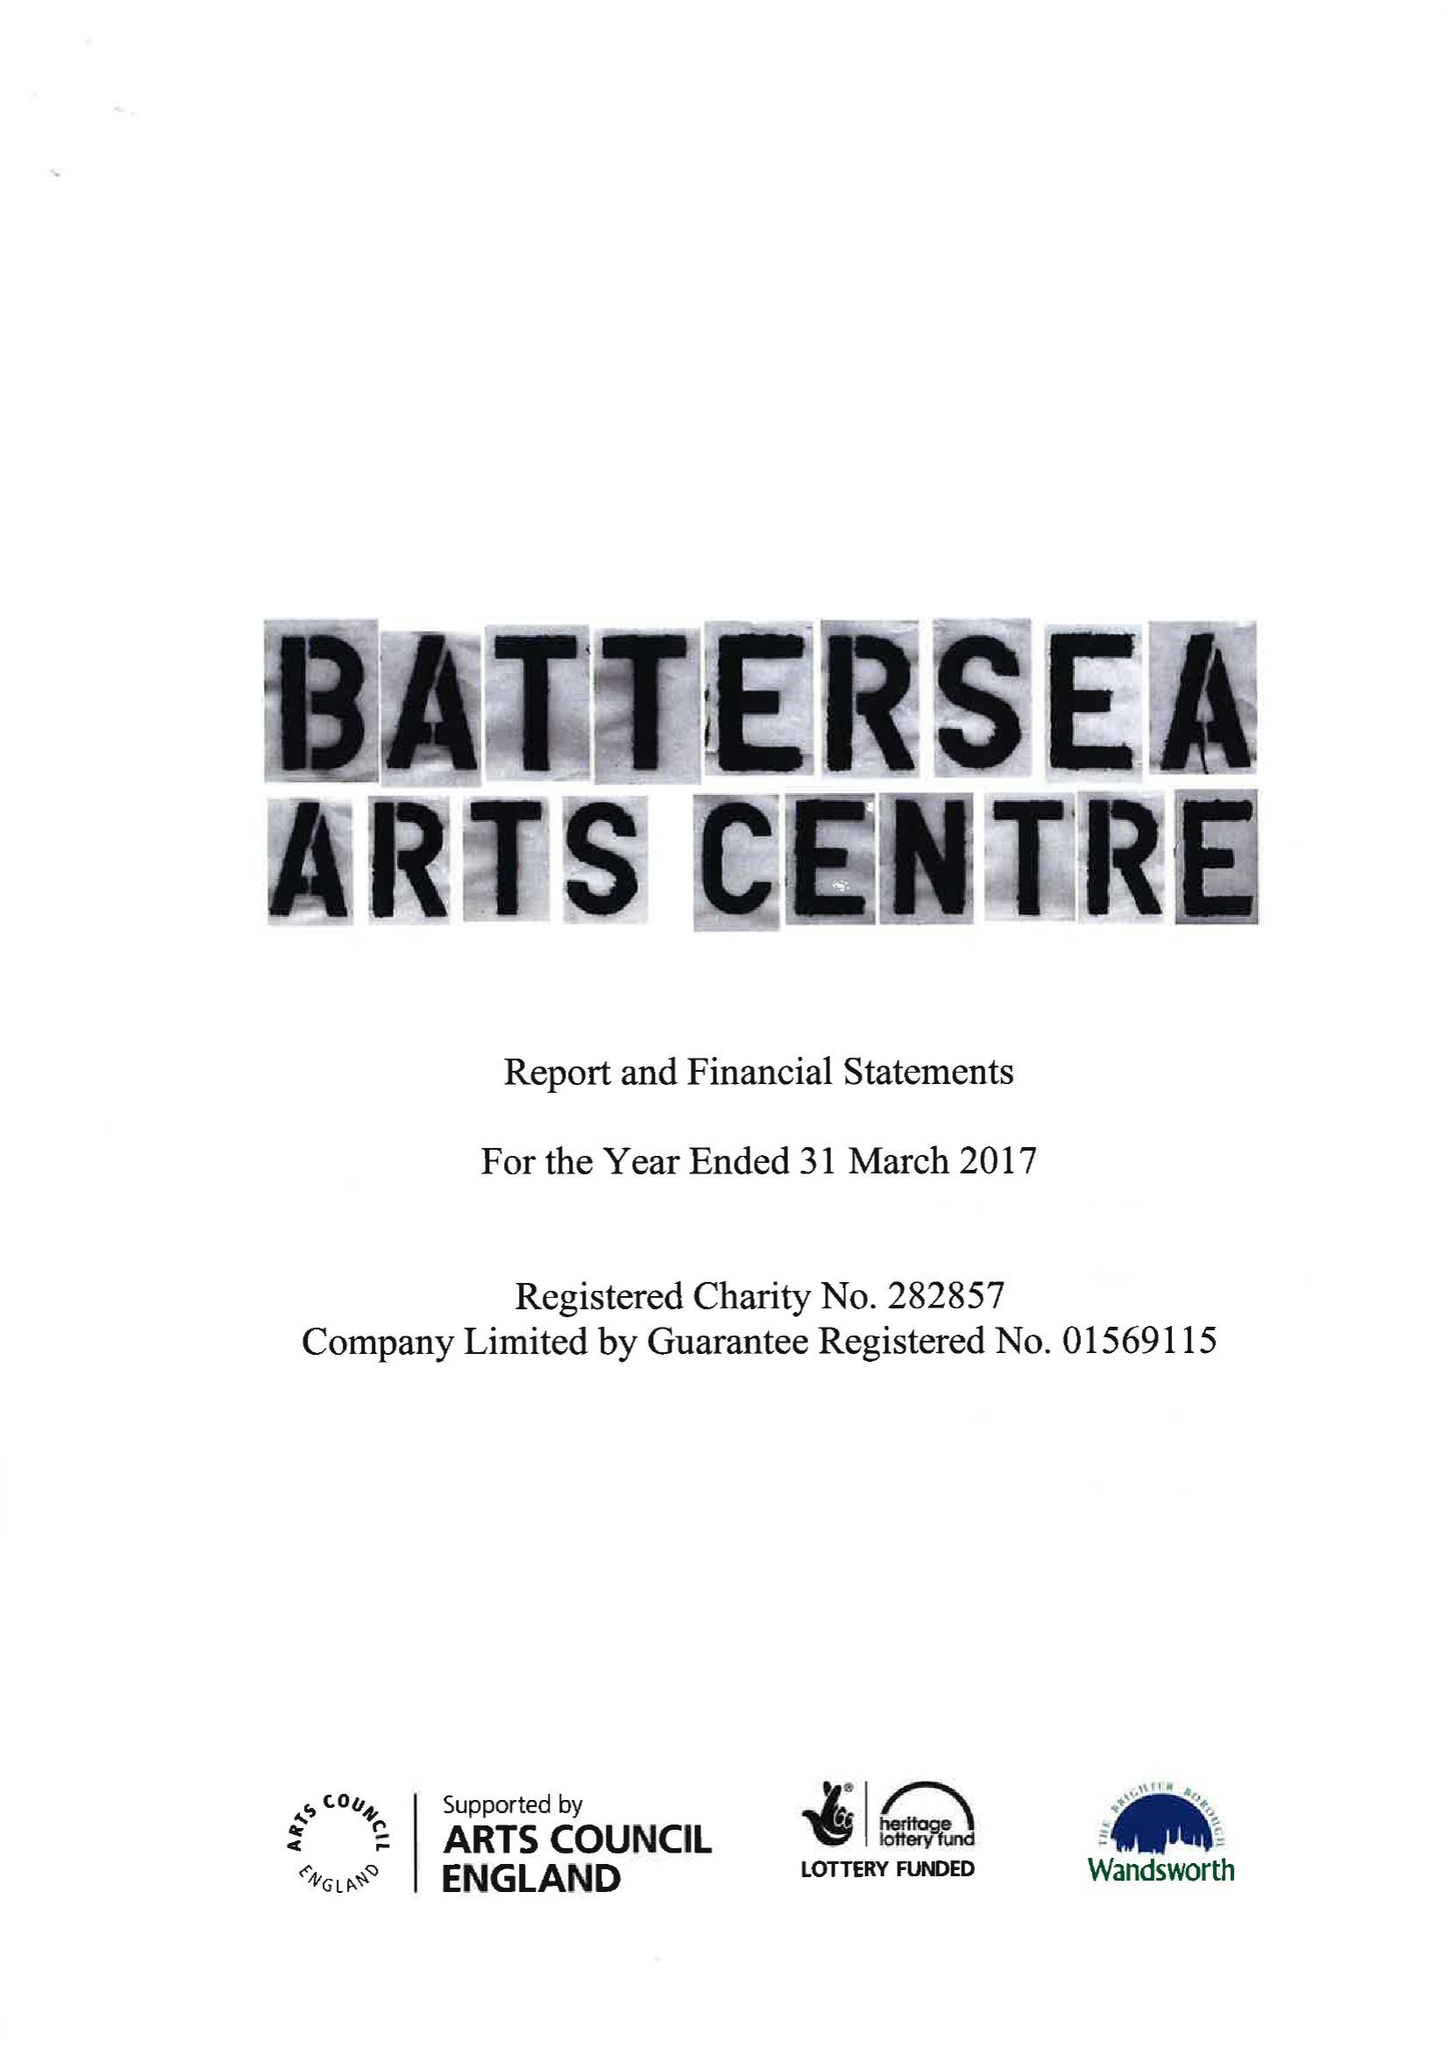What is the value for the charity_name?
Answer the question using a single word or phrase. Battersea Arts Centre 